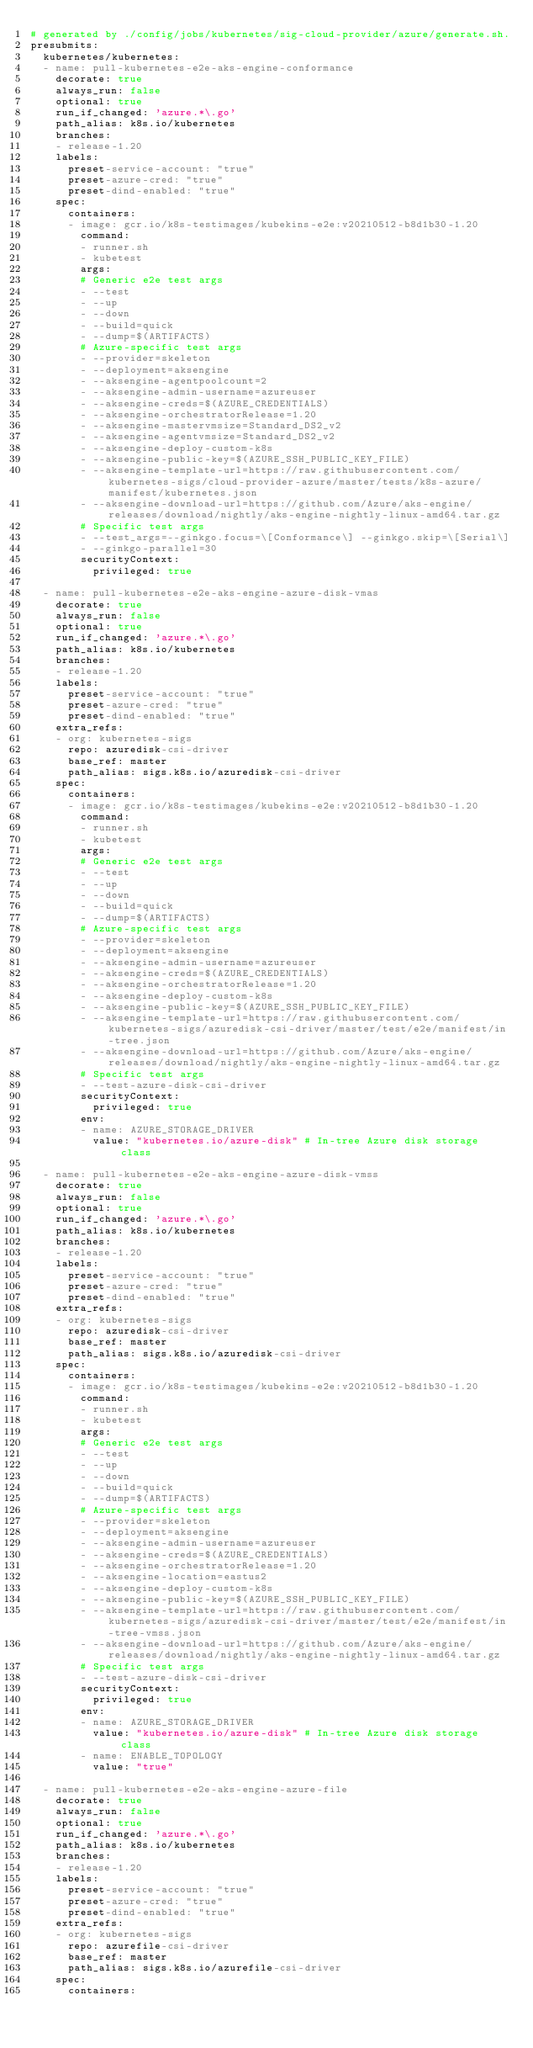<code> <loc_0><loc_0><loc_500><loc_500><_YAML_># generated by ./config/jobs/kubernetes/sig-cloud-provider/azure/generate.sh.
presubmits:
  kubernetes/kubernetes:
  - name: pull-kubernetes-e2e-aks-engine-conformance
    decorate: true
    always_run: false
    optional: true
    run_if_changed: 'azure.*\.go'
    path_alias: k8s.io/kubernetes
    branches:
    - release-1.20
    labels:
      preset-service-account: "true"
      preset-azure-cred: "true"
      preset-dind-enabled: "true"
    spec:
      containers:
      - image: gcr.io/k8s-testimages/kubekins-e2e:v20210512-b8d1b30-1.20
        command:
        - runner.sh
        - kubetest
        args:
        # Generic e2e test args
        - --test
        - --up
        - --down
        - --build=quick
        - --dump=$(ARTIFACTS)
        # Azure-specific test args
        - --provider=skeleton
        - --deployment=aksengine
        - --aksengine-agentpoolcount=2
        - --aksengine-admin-username=azureuser
        - --aksengine-creds=$(AZURE_CREDENTIALS)
        - --aksengine-orchestratorRelease=1.20
        - --aksengine-mastervmsize=Standard_DS2_v2
        - --aksengine-agentvmsize=Standard_DS2_v2
        - --aksengine-deploy-custom-k8s
        - --aksengine-public-key=$(AZURE_SSH_PUBLIC_KEY_FILE)
        - --aksengine-template-url=https://raw.githubusercontent.com/kubernetes-sigs/cloud-provider-azure/master/tests/k8s-azure/manifest/kubernetes.json
        - --aksengine-download-url=https://github.com/Azure/aks-engine/releases/download/nightly/aks-engine-nightly-linux-amd64.tar.gz
        # Specific test args
        - --test_args=--ginkgo.focus=\[Conformance\] --ginkgo.skip=\[Serial\]
        - --ginkgo-parallel=30
        securityContext:
          privileged: true

  - name: pull-kubernetes-e2e-aks-engine-azure-disk-vmas
    decorate: true
    always_run: false
    optional: true
    run_if_changed: 'azure.*\.go'
    path_alias: k8s.io/kubernetes
    branches:
    - release-1.20
    labels:
      preset-service-account: "true"
      preset-azure-cred: "true"
      preset-dind-enabled: "true"
    extra_refs:
    - org: kubernetes-sigs
      repo: azuredisk-csi-driver
      base_ref: master
      path_alias: sigs.k8s.io/azuredisk-csi-driver
    spec:
      containers:
      - image: gcr.io/k8s-testimages/kubekins-e2e:v20210512-b8d1b30-1.20
        command:
        - runner.sh
        - kubetest
        args:
        # Generic e2e test args
        - --test
        - --up
        - --down
        - --build=quick
        - --dump=$(ARTIFACTS)
        # Azure-specific test args
        - --provider=skeleton
        - --deployment=aksengine
        - --aksengine-admin-username=azureuser
        - --aksengine-creds=$(AZURE_CREDENTIALS)
        - --aksengine-orchestratorRelease=1.20
        - --aksengine-deploy-custom-k8s
        - --aksengine-public-key=$(AZURE_SSH_PUBLIC_KEY_FILE)
        - --aksengine-template-url=https://raw.githubusercontent.com/kubernetes-sigs/azuredisk-csi-driver/master/test/e2e/manifest/in-tree.json
        - --aksengine-download-url=https://github.com/Azure/aks-engine/releases/download/nightly/aks-engine-nightly-linux-amd64.tar.gz
        # Specific test args
        - --test-azure-disk-csi-driver
        securityContext:
          privileged: true
        env:
        - name: AZURE_STORAGE_DRIVER
          value: "kubernetes.io/azure-disk" # In-tree Azure disk storage class

  - name: pull-kubernetes-e2e-aks-engine-azure-disk-vmss
    decorate: true
    always_run: false
    optional: true
    run_if_changed: 'azure.*\.go'
    path_alias: k8s.io/kubernetes
    branches:
    - release-1.20
    labels:
      preset-service-account: "true"
      preset-azure-cred: "true"
      preset-dind-enabled: "true"
    extra_refs:
    - org: kubernetes-sigs
      repo: azuredisk-csi-driver
      base_ref: master
      path_alias: sigs.k8s.io/azuredisk-csi-driver
    spec:
      containers:
      - image: gcr.io/k8s-testimages/kubekins-e2e:v20210512-b8d1b30-1.20
        command:
        - runner.sh
        - kubetest
        args:
        # Generic e2e test args
        - --test
        - --up
        - --down
        - --build=quick
        - --dump=$(ARTIFACTS)
        # Azure-specific test args
        - --provider=skeleton
        - --deployment=aksengine
        - --aksengine-admin-username=azureuser
        - --aksengine-creds=$(AZURE_CREDENTIALS)
        - --aksengine-orchestratorRelease=1.20
        - --aksengine-location=eastus2
        - --aksengine-deploy-custom-k8s
        - --aksengine-public-key=$(AZURE_SSH_PUBLIC_KEY_FILE)
        - --aksengine-template-url=https://raw.githubusercontent.com/kubernetes-sigs/azuredisk-csi-driver/master/test/e2e/manifest/in-tree-vmss.json
        - --aksengine-download-url=https://github.com/Azure/aks-engine/releases/download/nightly/aks-engine-nightly-linux-amd64.tar.gz
        # Specific test args
        - --test-azure-disk-csi-driver
        securityContext:
          privileged: true
        env:
        - name: AZURE_STORAGE_DRIVER
          value: "kubernetes.io/azure-disk" # In-tree Azure disk storage class
        - name: ENABLE_TOPOLOGY
          value: "true"

  - name: pull-kubernetes-e2e-aks-engine-azure-file
    decorate: true
    always_run: false
    optional: true
    run_if_changed: 'azure.*\.go'
    path_alias: k8s.io/kubernetes
    branches:
    - release-1.20
    labels:
      preset-service-account: "true"
      preset-azure-cred: "true"
      preset-dind-enabled: "true"
    extra_refs:
    - org: kubernetes-sigs
      repo: azurefile-csi-driver
      base_ref: master
      path_alias: sigs.k8s.io/azurefile-csi-driver
    spec:
      containers:</code> 